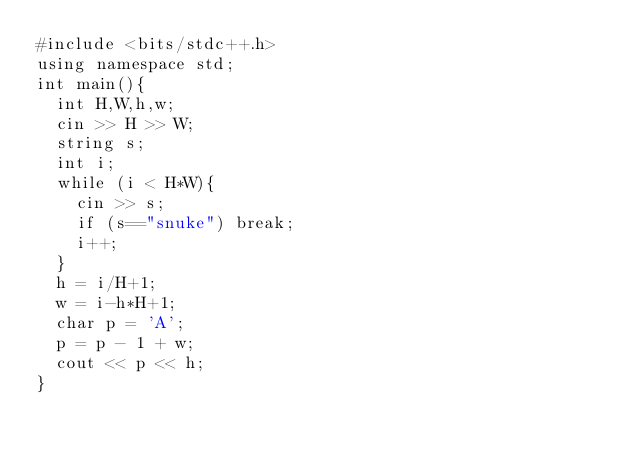Convert code to text. <code><loc_0><loc_0><loc_500><loc_500><_C++_>#include <bits/stdc++.h>
using namespace std;
int main(){
  int H,W,h,w;
  cin >> H >> W;
  string s;
  int i;
  while (i < H*W){
    cin >> s;
    if (s=="snuke") break;
    i++;
  }
  h = i/H+1;
  w = i-h*H+1;
  char p = 'A';
  p = p - 1 + w;
  cout << p << h;
}</code> 